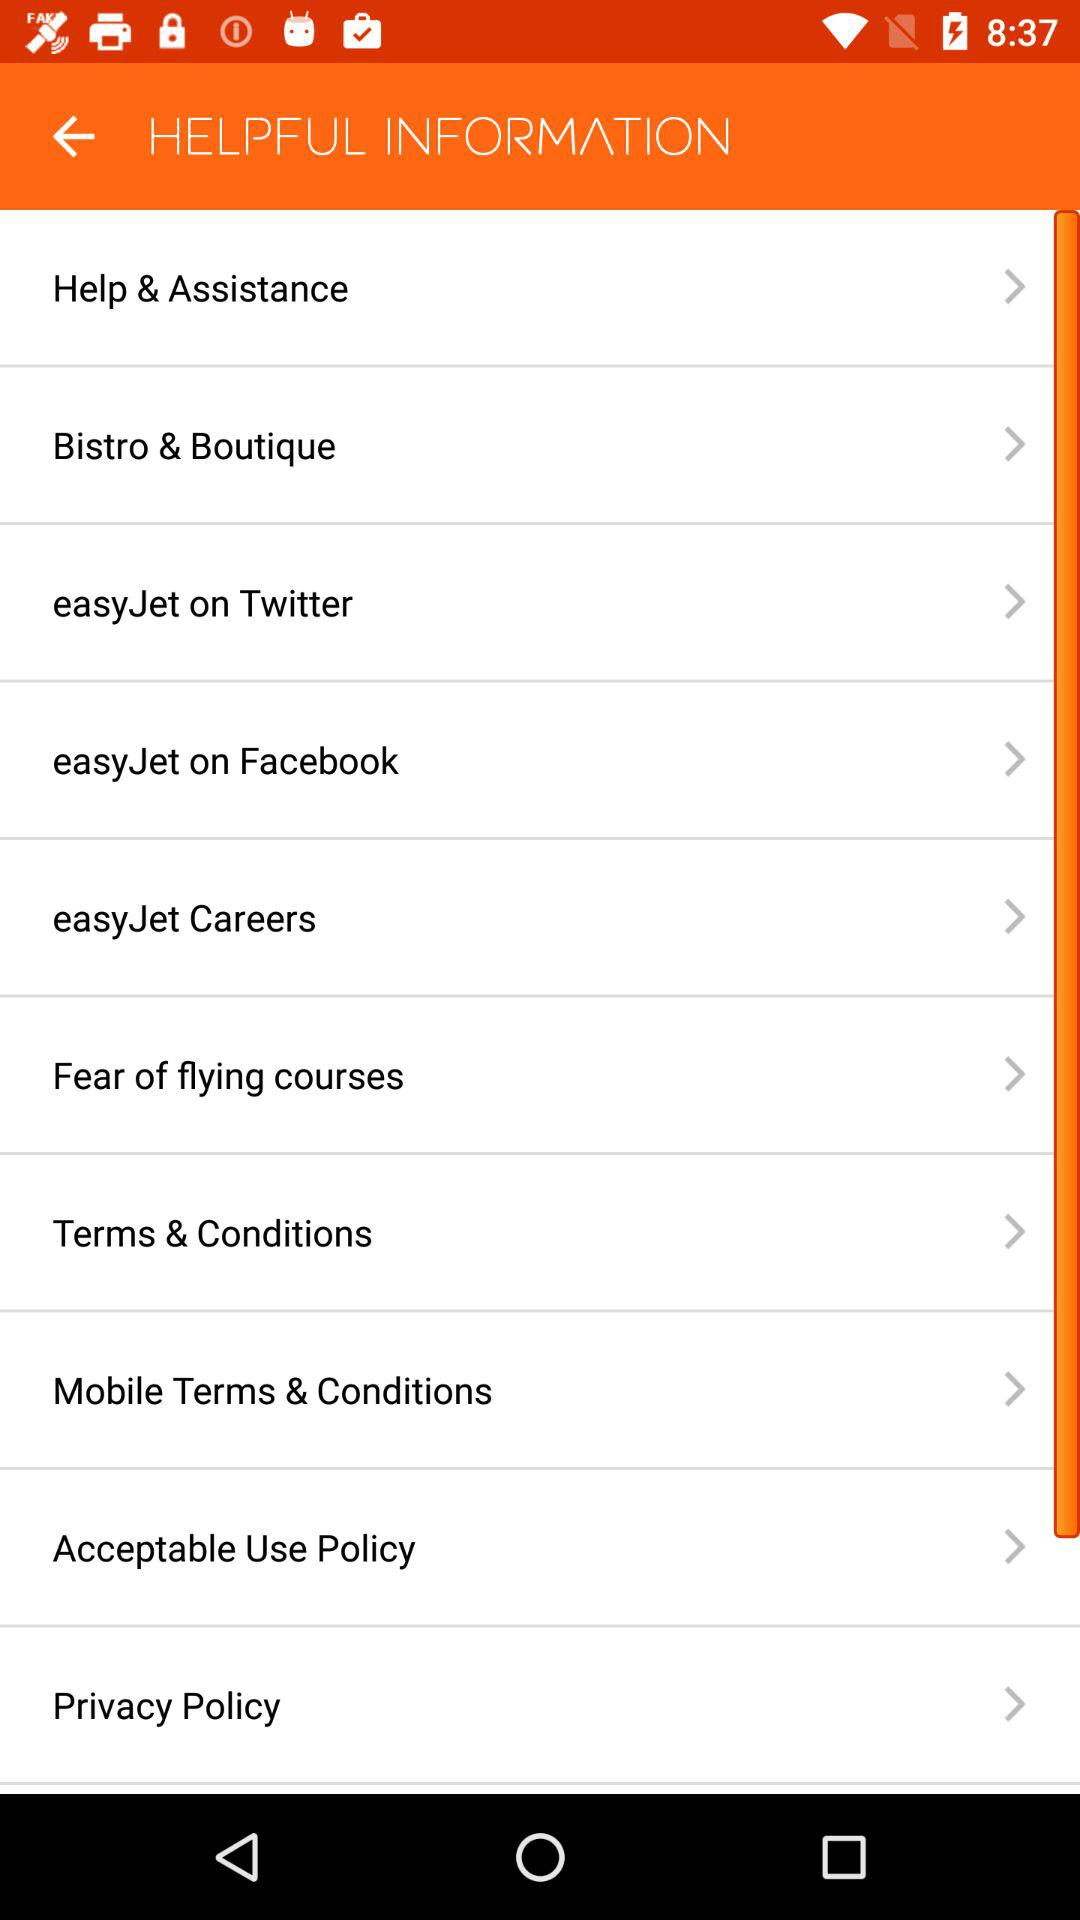What are the options available in "HELPFUL INFORMATION"? The options available in "HELPFUL INFORMATION" are "Help & Assistance", "Bistro & Boutique", "easyJet on Twitter", "easyJet on Facebook", "easyJet Careers", "Fear of flying courses", "Terms & Conditions", "Mobile Terms & Conditions", "Acceptable Use Policy" and "Privacy Policy". 